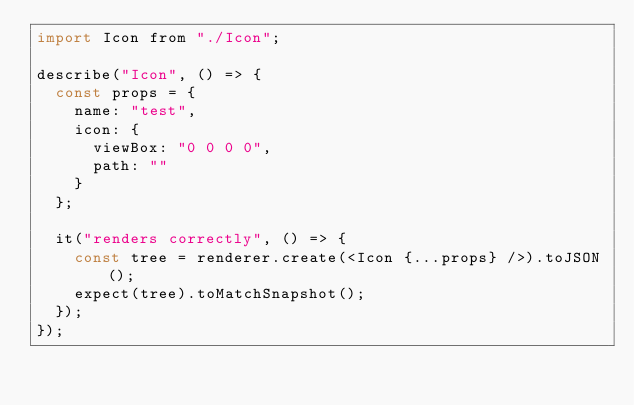<code> <loc_0><loc_0><loc_500><loc_500><_JavaScript_>import Icon from "./Icon";

describe("Icon", () => {
  const props = {
    name: "test",
    icon: {
      viewBox: "0 0 0 0",
      path: ""
    }
  };

  it("renders correctly", () => {
    const tree = renderer.create(<Icon {...props} />).toJSON();
    expect(tree).toMatchSnapshot();
  });
});
</code> 